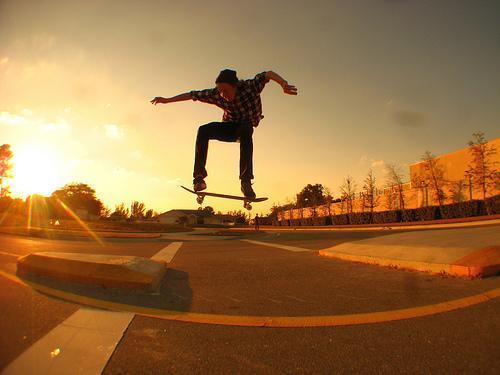How many people are in the photo?
Give a very brief answer. 1. 